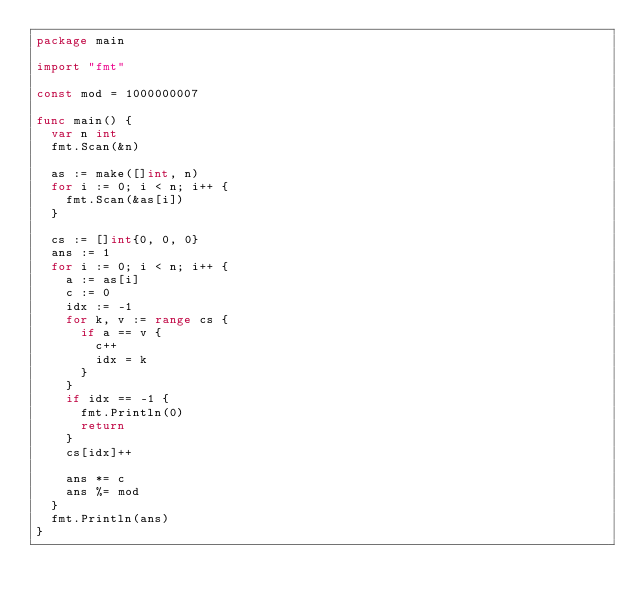Convert code to text. <code><loc_0><loc_0><loc_500><loc_500><_Go_>package main

import "fmt"

const mod = 1000000007

func main() {
	var n int
	fmt.Scan(&n)

	as := make([]int, n)
	for i := 0; i < n; i++ {
		fmt.Scan(&as[i])
	}

	cs := []int{0, 0, 0}
	ans := 1
	for i := 0; i < n; i++ {
		a := as[i]
		c := 0
		idx := -1
		for k, v := range cs {
			if a == v {
				c++
				idx = k
			}
		}
		if idx == -1 {
			fmt.Println(0)
			return
		}
		cs[idx]++

		ans *= c
		ans %= mod
	}
	fmt.Println(ans)
}
</code> 